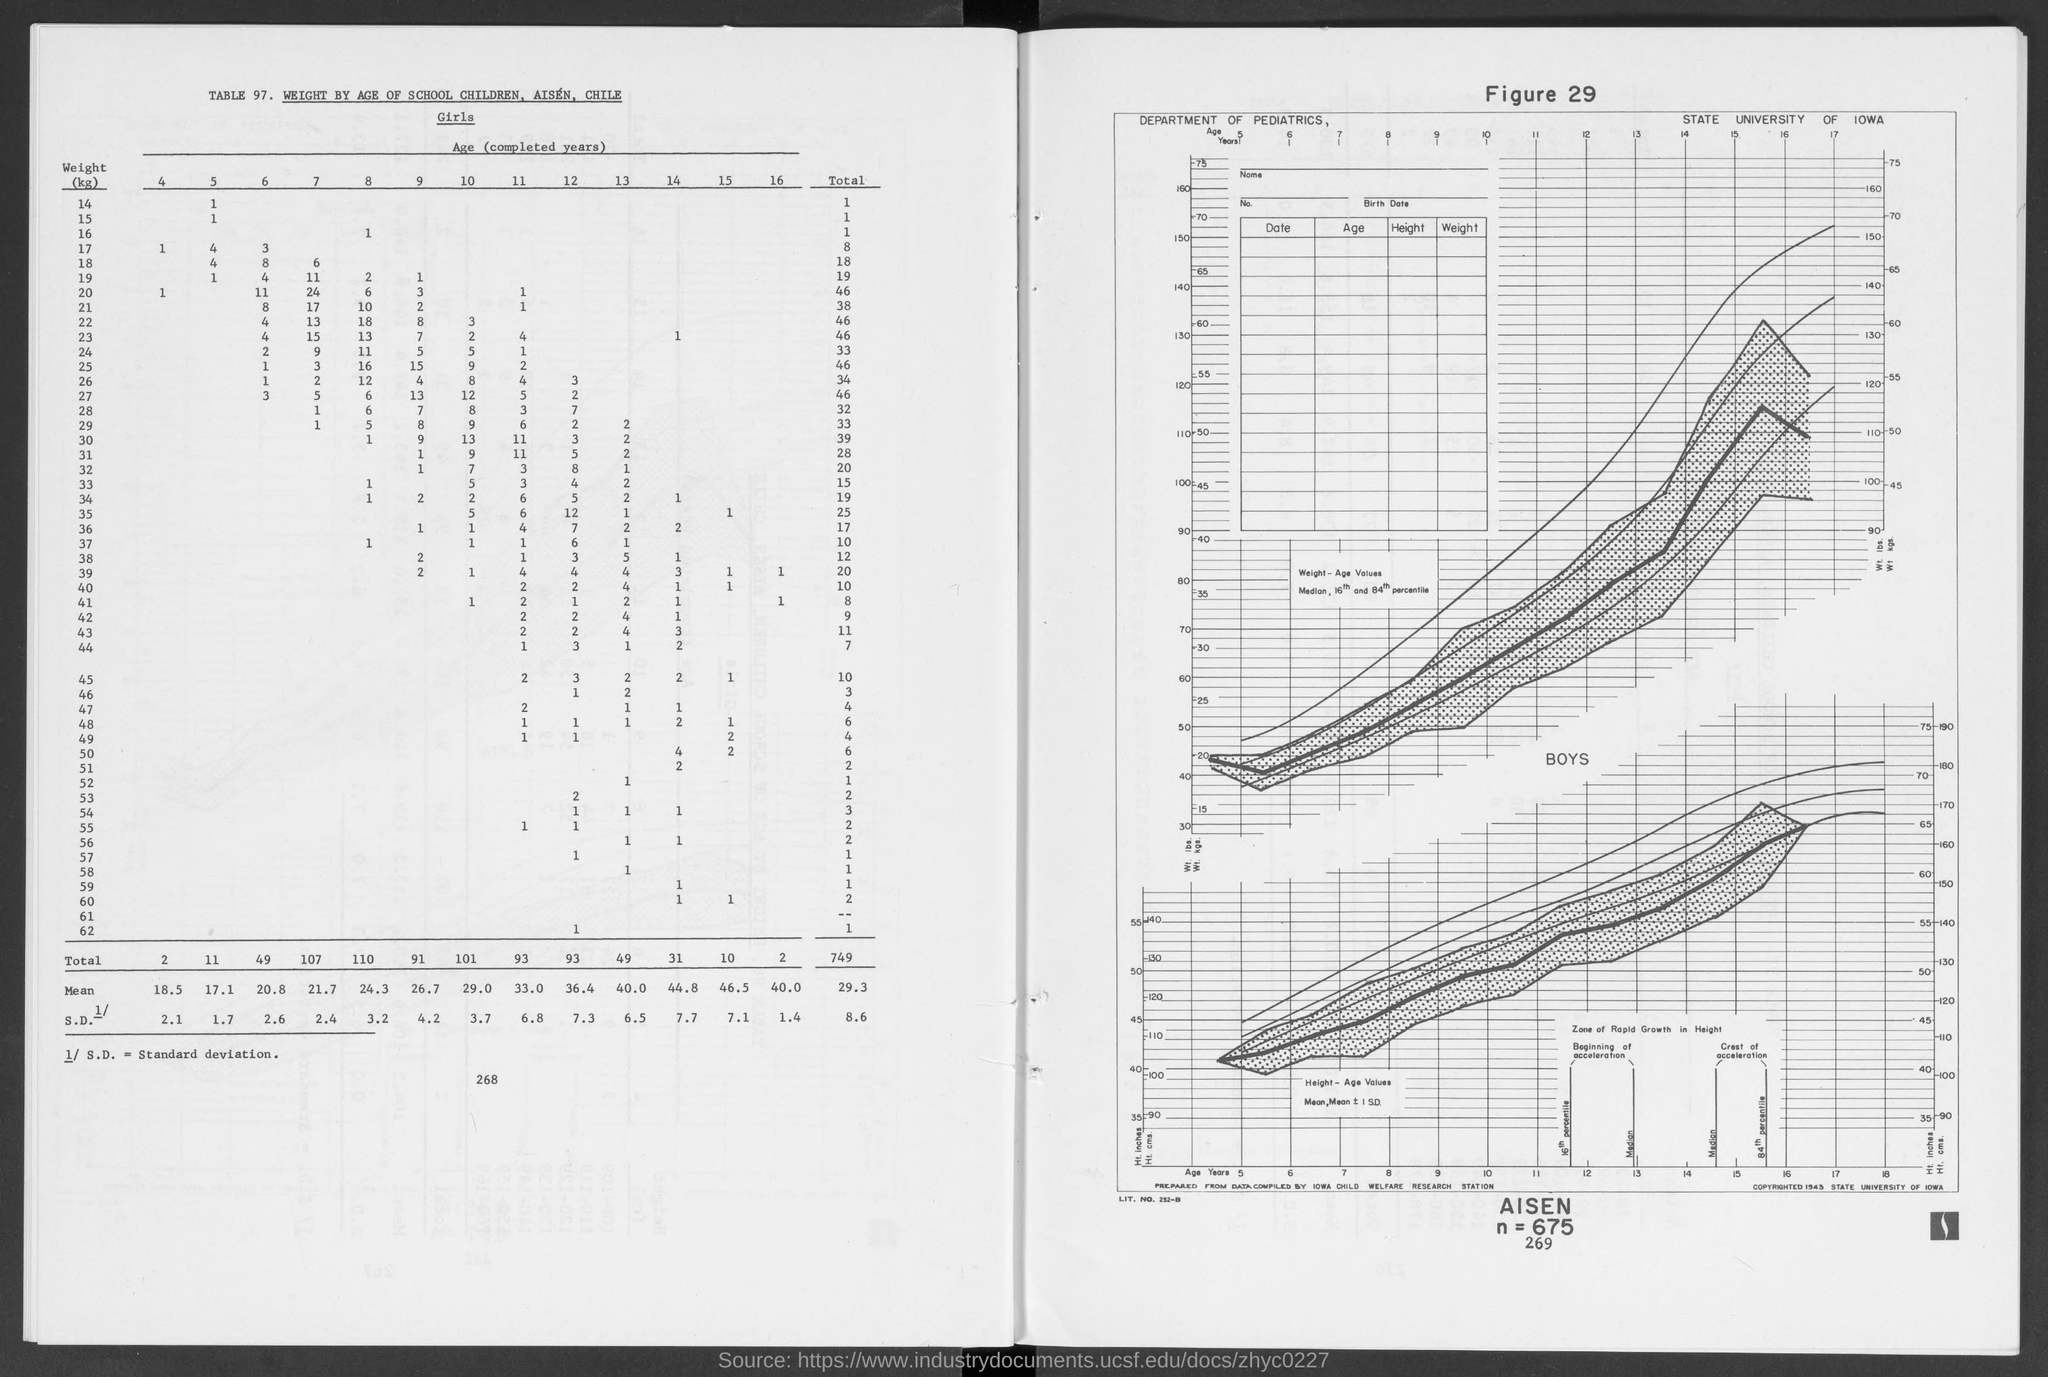Highlight a few significant elements in this photo. The total number of children weighing 45 is 10. The number of children who weigh 17 and are 6 years old is 3. There is one child who is 5 years old and weighs 14 kilograms. 